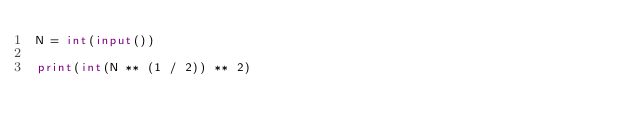<code> <loc_0><loc_0><loc_500><loc_500><_Python_>N = int(input())

print(int(N ** (1 / 2)) ** 2)

</code> 